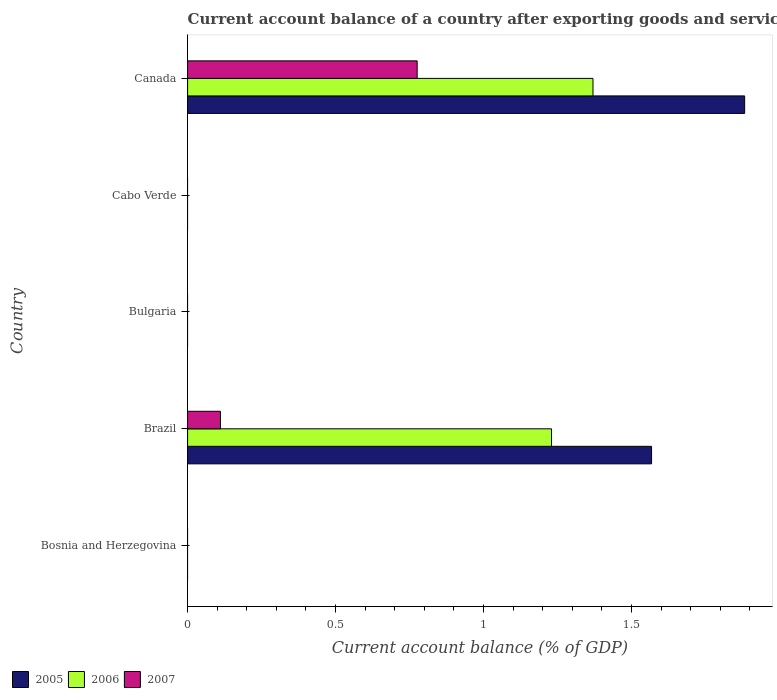How many different coloured bars are there?
Your answer should be very brief. 3. Are the number of bars per tick equal to the number of legend labels?
Ensure brevity in your answer.  No. Are the number of bars on each tick of the Y-axis equal?
Keep it short and to the point. No. How many bars are there on the 1st tick from the top?
Offer a terse response. 3. How many bars are there on the 4th tick from the bottom?
Your answer should be very brief. 0. In how many cases, is the number of bars for a given country not equal to the number of legend labels?
Ensure brevity in your answer.  3. What is the account balance in 2006 in Canada?
Make the answer very short. 1.37. Across all countries, what is the maximum account balance in 2005?
Your response must be concise. 1.88. What is the total account balance in 2006 in the graph?
Keep it short and to the point. 2.6. What is the difference between the account balance in 2007 in Brazil and that in Canada?
Make the answer very short. -0.66. What is the difference between the account balance in 2006 in Brazil and the account balance in 2005 in Cabo Verde?
Keep it short and to the point. 1.23. What is the average account balance in 2005 per country?
Keep it short and to the point. 0.69. What is the difference between the account balance in 2005 and account balance in 2006 in Brazil?
Your answer should be compact. 0.34. In how many countries, is the account balance in 2005 greater than 0.5 %?
Provide a succinct answer. 2. What is the ratio of the account balance in 2007 in Brazil to that in Canada?
Keep it short and to the point. 0.14. What is the difference between the highest and the lowest account balance in 2006?
Your answer should be compact. 1.37. Is the sum of the account balance in 2007 in Brazil and Canada greater than the maximum account balance in 2006 across all countries?
Make the answer very short. No. How many countries are there in the graph?
Provide a succinct answer. 5. What is the difference between two consecutive major ticks on the X-axis?
Offer a very short reply. 0.5. Are the values on the major ticks of X-axis written in scientific E-notation?
Your response must be concise. No. Does the graph contain grids?
Make the answer very short. No. Where does the legend appear in the graph?
Your answer should be very brief. Bottom left. How many legend labels are there?
Give a very brief answer. 3. How are the legend labels stacked?
Keep it short and to the point. Horizontal. What is the title of the graph?
Provide a succinct answer. Current account balance of a country after exporting goods and services. What is the label or title of the X-axis?
Provide a short and direct response. Current account balance (% of GDP). What is the label or title of the Y-axis?
Your answer should be very brief. Country. What is the Current account balance (% of GDP) of 2006 in Bosnia and Herzegovina?
Your answer should be compact. 0. What is the Current account balance (% of GDP) in 2005 in Brazil?
Your response must be concise. 1.57. What is the Current account balance (% of GDP) of 2006 in Brazil?
Keep it short and to the point. 1.23. What is the Current account balance (% of GDP) of 2007 in Brazil?
Your response must be concise. 0.11. What is the Current account balance (% of GDP) in 2005 in Bulgaria?
Ensure brevity in your answer.  0. What is the Current account balance (% of GDP) in 2005 in Canada?
Your answer should be very brief. 1.88. What is the Current account balance (% of GDP) in 2006 in Canada?
Give a very brief answer. 1.37. What is the Current account balance (% of GDP) of 2007 in Canada?
Provide a short and direct response. 0.78. Across all countries, what is the maximum Current account balance (% of GDP) in 2005?
Offer a terse response. 1.88. Across all countries, what is the maximum Current account balance (% of GDP) in 2006?
Keep it short and to the point. 1.37. Across all countries, what is the maximum Current account balance (% of GDP) of 2007?
Keep it short and to the point. 0.78. Across all countries, what is the minimum Current account balance (% of GDP) of 2005?
Keep it short and to the point. 0. Across all countries, what is the minimum Current account balance (% of GDP) in 2006?
Your answer should be compact. 0. What is the total Current account balance (% of GDP) of 2005 in the graph?
Offer a very short reply. 3.45. What is the total Current account balance (% of GDP) of 2006 in the graph?
Keep it short and to the point. 2.6. What is the total Current account balance (% of GDP) in 2007 in the graph?
Your answer should be compact. 0.89. What is the difference between the Current account balance (% of GDP) in 2005 in Brazil and that in Canada?
Offer a very short reply. -0.31. What is the difference between the Current account balance (% of GDP) of 2006 in Brazil and that in Canada?
Your answer should be compact. -0.14. What is the difference between the Current account balance (% of GDP) of 2007 in Brazil and that in Canada?
Your answer should be compact. -0.66. What is the difference between the Current account balance (% of GDP) of 2005 in Brazil and the Current account balance (% of GDP) of 2006 in Canada?
Give a very brief answer. 0.2. What is the difference between the Current account balance (% of GDP) in 2005 in Brazil and the Current account balance (% of GDP) in 2007 in Canada?
Your response must be concise. 0.79. What is the difference between the Current account balance (% of GDP) of 2006 in Brazil and the Current account balance (% of GDP) of 2007 in Canada?
Provide a succinct answer. 0.45. What is the average Current account balance (% of GDP) in 2005 per country?
Make the answer very short. 0.69. What is the average Current account balance (% of GDP) in 2006 per country?
Offer a terse response. 0.52. What is the average Current account balance (% of GDP) in 2007 per country?
Keep it short and to the point. 0.18. What is the difference between the Current account balance (% of GDP) in 2005 and Current account balance (% of GDP) in 2006 in Brazil?
Provide a succinct answer. 0.34. What is the difference between the Current account balance (% of GDP) in 2005 and Current account balance (% of GDP) in 2007 in Brazil?
Ensure brevity in your answer.  1.46. What is the difference between the Current account balance (% of GDP) of 2006 and Current account balance (% of GDP) of 2007 in Brazil?
Your answer should be compact. 1.12. What is the difference between the Current account balance (% of GDP) of 2005 and Current account balance (% of GDP) of 2006 in Canada?
Provide a short and direct response. 0.51. What is the difference between the Current account balance (% of GDP) of 2005 and Current account balance (% of GDP) of 2007 in Canada?
Offer a terse response. 1.11. What is the difference between the Current account balance (% of GDP) in 2006 and Current account balance (% of GDP) in 2007 in Canada?
Provide a succinct answer. 0.59. What is the ratio of the Current account balance (% of GDP) of 2005 in Brazil to that in Canada?
Your response must be concise. 0.83. What is the ratio of the Current account balance (% of GDP) of 2006 in Brazil to that in Canada?
Your response must be concise. 0.9. What is the ratio of the Current account balance (% of GDP) of 2007 in Brazil to that in Canada?
Provide a short and direct response. 0.14. What is the difference between the highest and the lowest Current account balance (% of GDP) in 2005?
Make the answer very short. 1.88. What is the difference between the highest and the lowest Current account balance (% of GDP) in 2006?
Ensure brevity in your answer.  1.37. What is the difference between the highest and the lowest Current account balance (% of GDP) in 2007?
Keep it short and to the point. 0.78. 